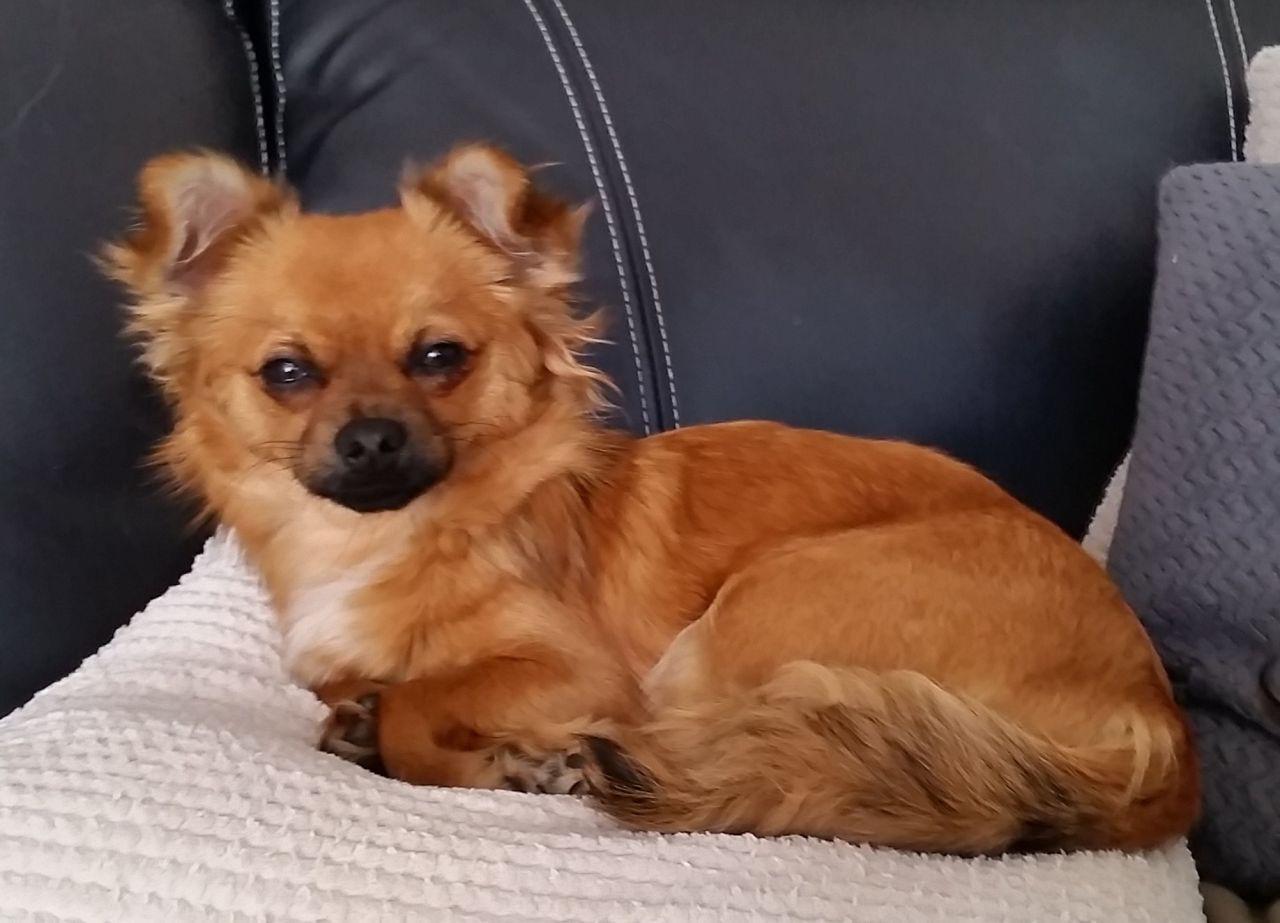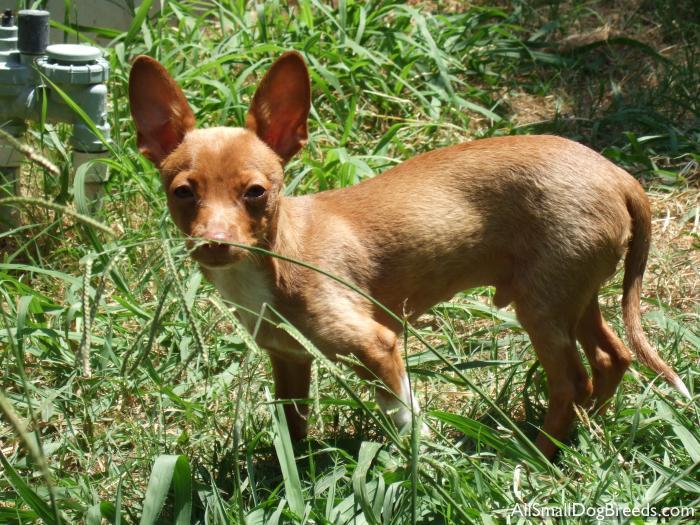The first image is the image on the left, the second image is the image on the right. Considering the images on both sides, is "The dog in the image on the left is looking toward the camera." valid? Answer yes or no. Yes. 